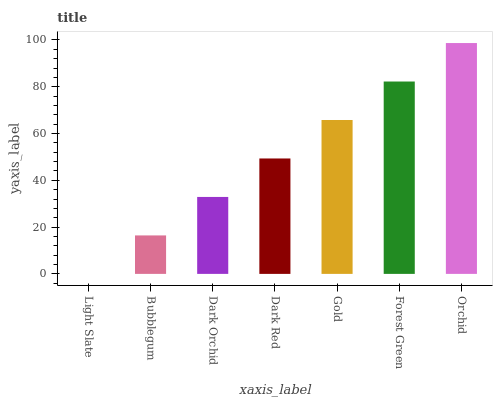Is Light Slate the minimum?
Answer yes or no. Yes. Is Orchid the maximum?
Answer yes or no. Yes. Is Bubblegum the minimum?
Answer yes or no. No. Is Bubblegum the maximum?
Answer yes or no. No. Is Bubblegum greater than Light Slate?
Answer yes or no. Yes. Is Light Slate less than Bubblegum?
Answer yes or no. Yes. Is Light Slate greater than Bubblegum?
Answer yes or no. No. Is Bubblegum less than Light Slate?
Answer yes or no. No. Is Dark Red the high median?
Answer yes or no. Yes. Is Dark Red the low median?
Answer yes or no. Yes. Is Dark Orchid the high median?
Answer yes or no. No. Is Light Slate the low median?
Answer yes or no. No. 